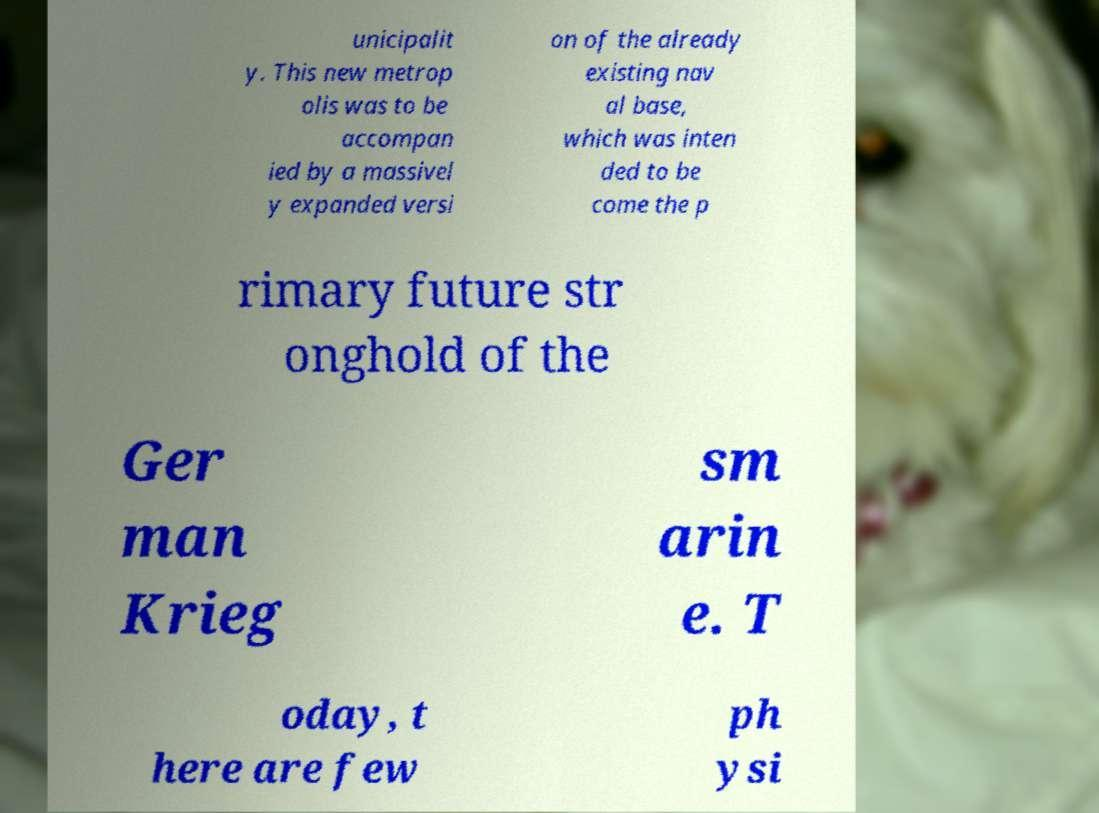I need the written content from this picture converted into text. Can you do that? unicipalit y. This new metrop olis was to be accompan ied by a massivel y expanded versi on of the already existing nav al base, which was inten ded to be come the p rimary future str onghold of the Ger man Krieg sm arin e. T oday, t here are few ph ysi 